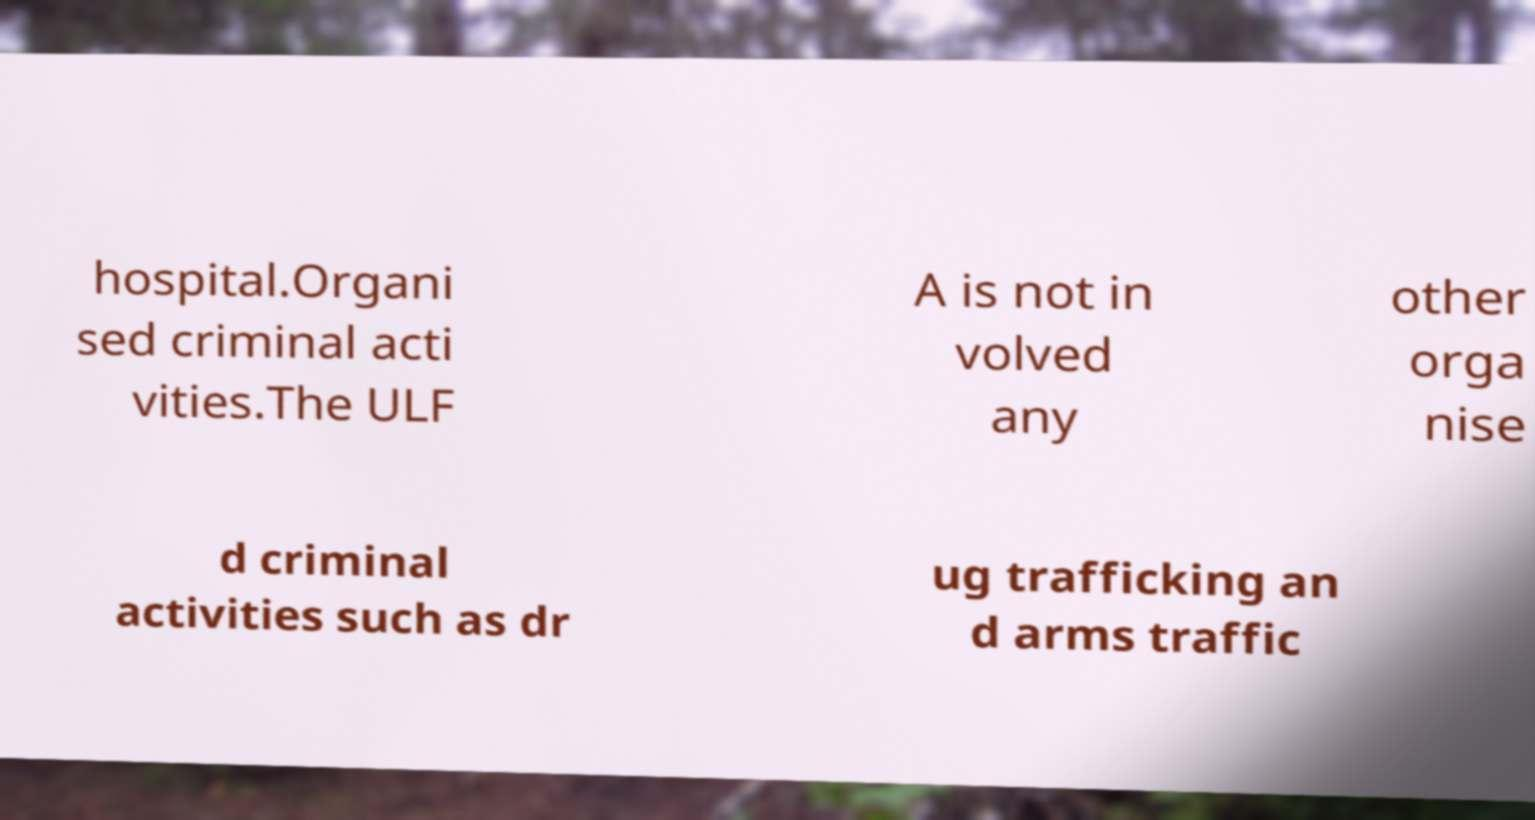What messages or text are displayed in this image? I need them in a readable, typed format. hospital.Organi sed criminal acti vities.The ULF A is not in volved any other orga nise d criminal activities such as dr ug trafficking an d arms traffic 